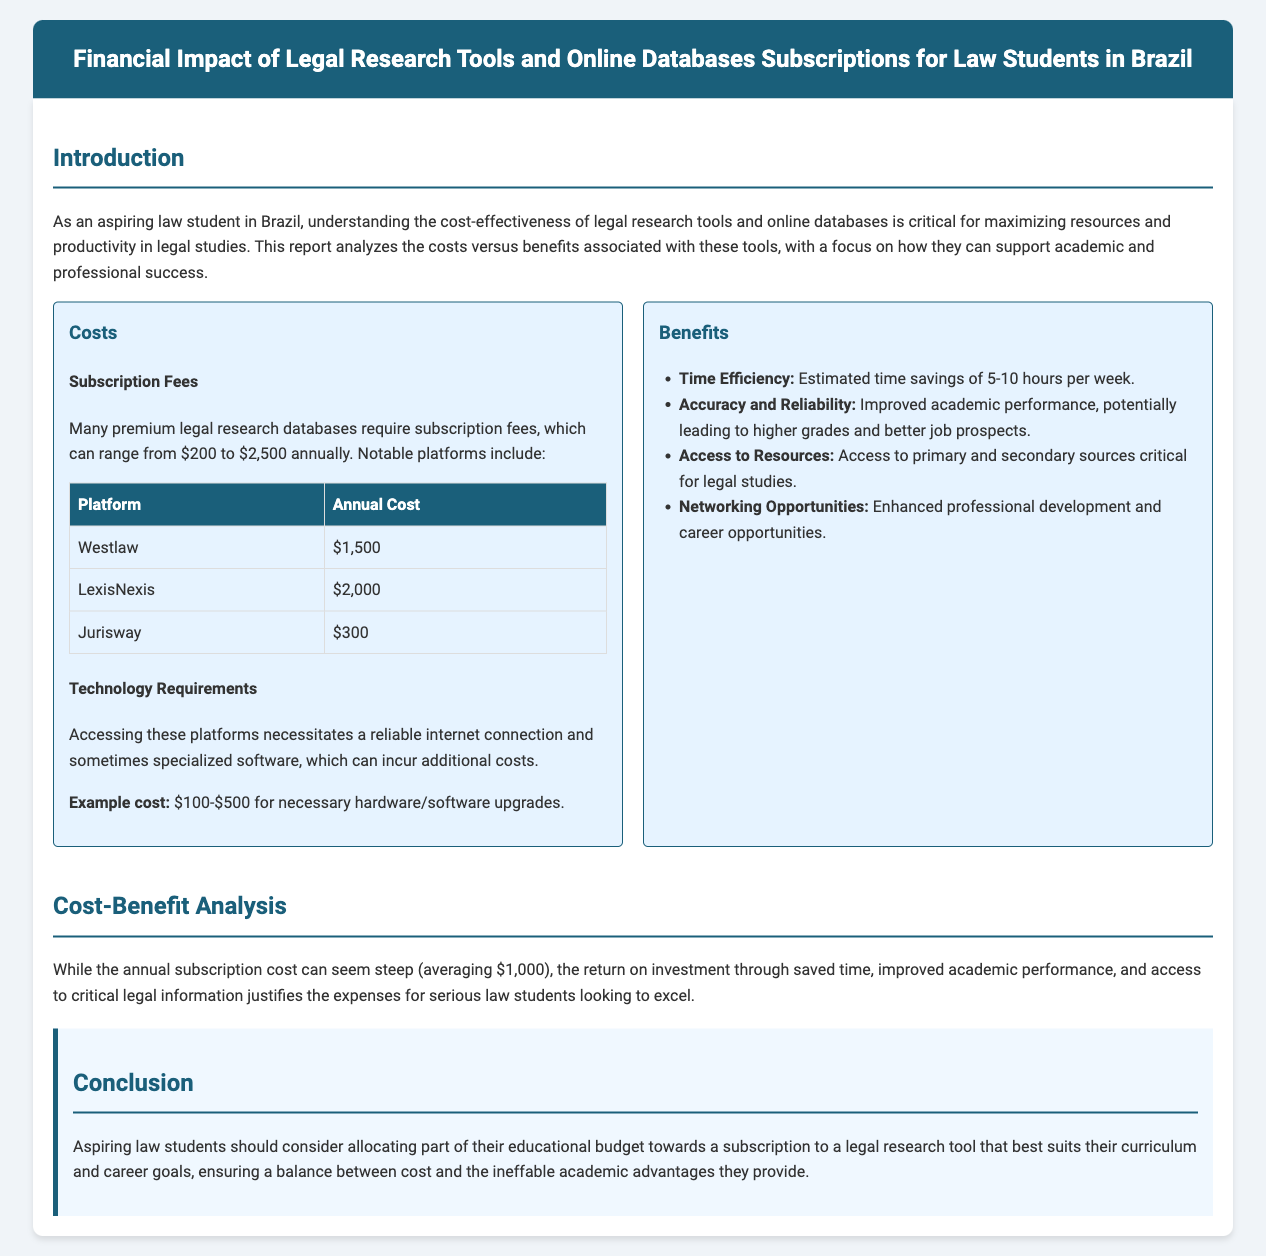What is the annual cost of Westlaw? The document provides a table listing the annual costs for different platforms, stating that Westlaw costs $1,500 annually.
Answer: $1,500 What are the estimated time savings per week? The benefits section mentions that legal research tools can save an estimated time of 5-10 hours per week.
Answer: 5-10 hours What is the average annual subscription cost mentioned? The document states that the average subscription cost is $1,000, which is part of the cost-benefit analysis.
Answer: $1,000 Which legal research platform has the highest subscription fee? The table lists the subscription fees, and it shows that LexisNexis has the highest fee at $2,000.
Answer: LexisNexis What type of opportunities do legal research tools enhance? The document mentions networking opportunities as one of the benefits provided by legal research tools.
Answer: Networking Opportunities What is the example cost for necessary hardware/software upgrades? The costs section mentions an example cost for upgrades ranging from $100 to $500.
Answer: $100-$500 What conclusion is drawn about the budget allocation for subscriptions? The conclusion emphasizes the importance of allocating part of the educational budget towards a subscription suited for law students' goals.
Answer: Allocate part of the educational budget What is one key benefit of using legal research tools according to the report? The benefits section outlines multiple advantages; one key benefit highlighted is improved academic performance.
Answer: Improved academic performance What technology is required to access these platforms? The costs section specifies that a reliable internet connection and sometimes specialized software are required.
Answer: Reliable internet connection and specialized software 